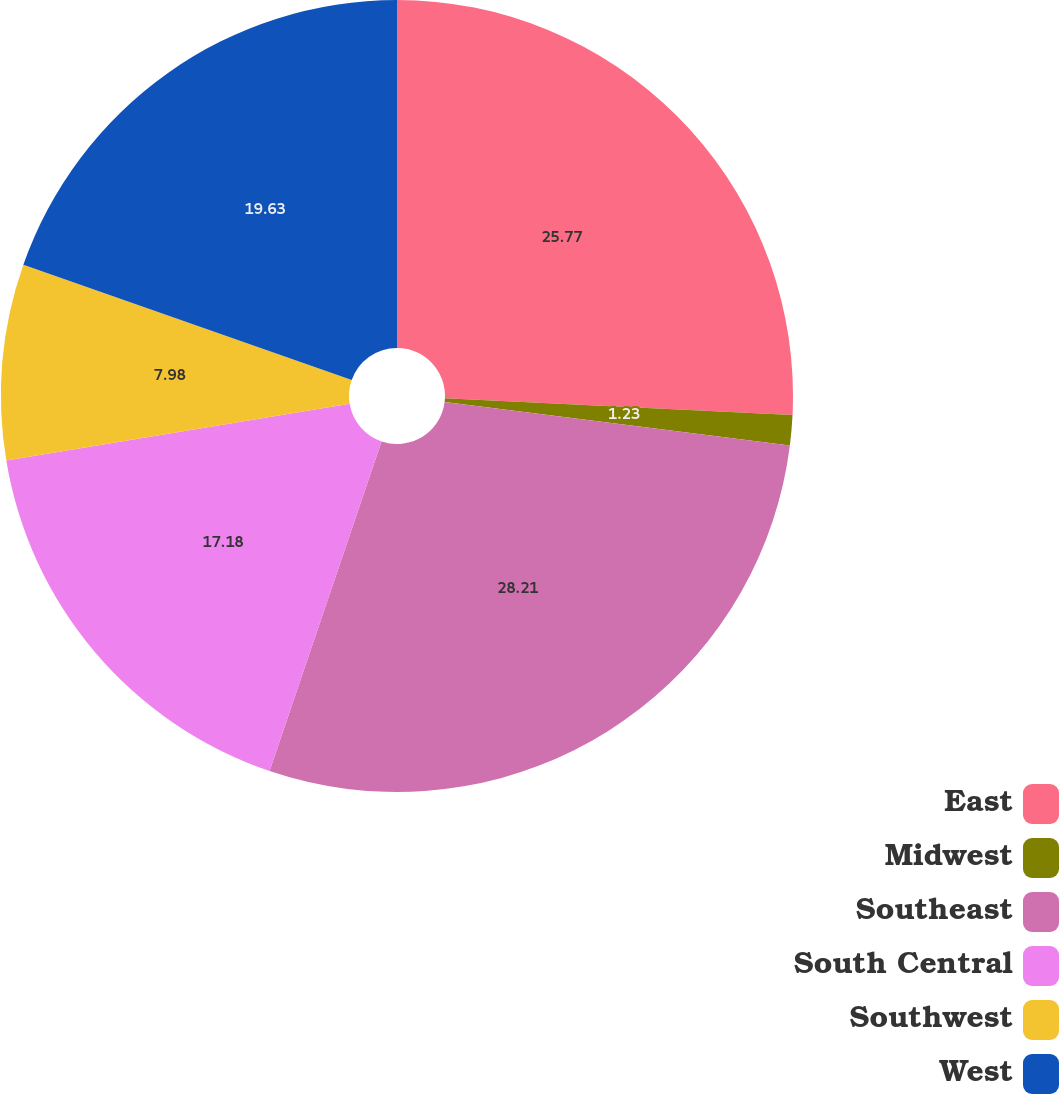Convert chart to OTSL. <chart><loc_0><loc_0><loc_500><loc_500><pie_chart><fcel>East<fcel>Midwest<fcel>Southeast<fcel>South Central<fcel>Southwest<fcel>West<nl><fcel>25.77%<fcel>1.23%<fcel>28.22%<fcel>17.18%<fcel>7.98%<fcel>19.63%<nl></chart> 